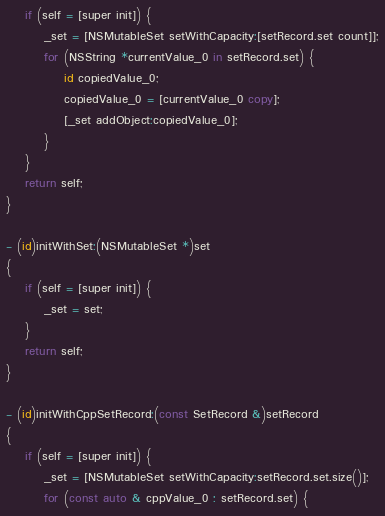Convert code to text. <code><loc_0><loc_0><loc_500><loc_500><_ObjectiveC_>    if (self = [super init]) {
        _set = [NSMutableSet setWithCapacity:[setRecord.set count]];
        for (NSString *currentValue_0 in setRecord.set) {
            id copiedValue_0;
            copiedValue_0 = [currentValue_0 copy];
            [_set addObject:copiedValue_0];
        }
    }
    return self;
}

- (id)initWithSet:(NSMutableSet *)set
{
    if (self = [super init]) {
        _set = set;
    }
    return self;
}

- (id)initWithCppSetRecord:(const SetRecord &)setRecord
{
    if (self = [super init]) {
        _set = [NSMutableSet setWithCapacity:setRecord.set.size()];
        for (const auto & cppValue_0 : setRecord.set) {</code> 